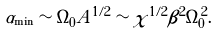Convert formula to latex. <formula><loc_0><loc_0><loc_500><loc_500>\alpha _ { \min } \sim \Omega _ { 0 } A ^ { 1 / 2 } \sim \chi ^ { 1 / 2 } \beta ^ { 2 } \Omega _ { 0 } ^ { 2 } .</formula> 